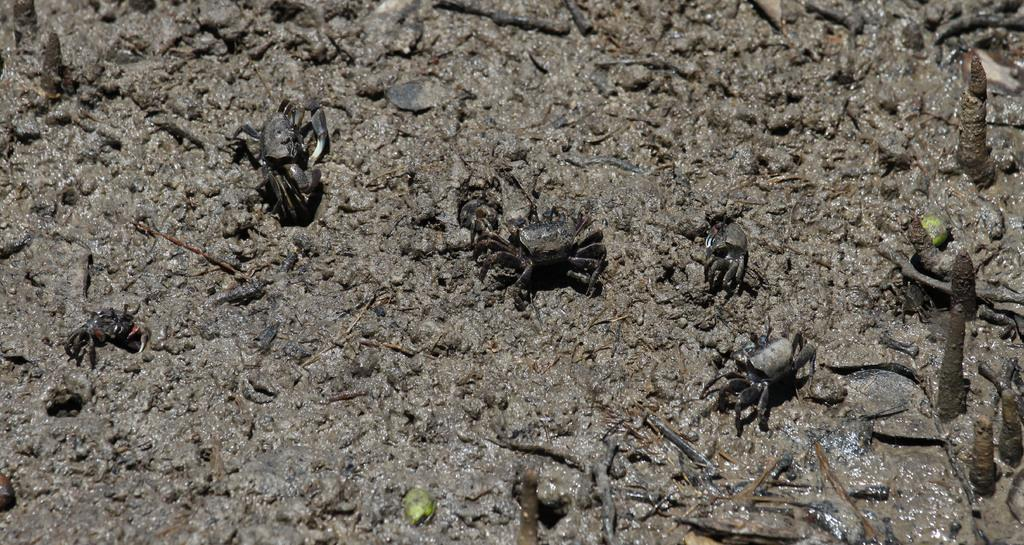What type of creatures can be seen in the image? There are insects in the image. What can be seen in the background of the image? There is mud and twigs in the background of the image. How many trains can be seen in the image? There are no trains present in the image. What type of debt is associated with the insects in the image? There is no mention of debt in the image, as it features insects and natural elements like mud and twigs. 